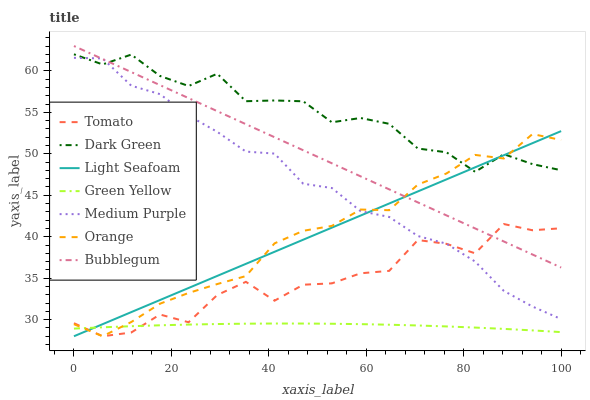Does Green Yellow have the minimum area under the curve?
Answer yes or no. Yes. Does Dark Green have the maximum area under the curve?
Answer yes or no. Yes. Does Light Seafoam have the minimum area under the curve?
Answer yes or no. No. Does Light Seafoam have the maximum area under the curve?
Answer yes or no. No. Is Bubblegum the smoothest?
Answer yes or no. Yes. Is Tomato the roughest?
Answer yes or no. Yes. Is Light Seafoam the smoothest?
Answer yes or no. No. Is Light Seafoam the roughest?
Answer yes or no. No. Does Tomato have the lowest value?
Answer yes or no. Yes. Does Bubblegum have the lowest value?
Answer yes or no. No. Does Bubblegum have the highest value?
Answer yes or no. Yes. Does Light Seafoam have the highest value?
Answer yes or no. No. Is Tomato less than Dark Green?
Answer yes or no. Yes. Is Dark Green greater than Green Yellow?
Answer yes or no. Yes. Does Dark Green intersect Medium Purple?
Answer yes or no. Yes. Is Dark Green less than Medium Purple?
Answer yes or no. No. Is Dark Green greater than Medium Purple?
Answer yes or no. No. Does Tomato intersect Dark Green?
Answer yes or no. No. 